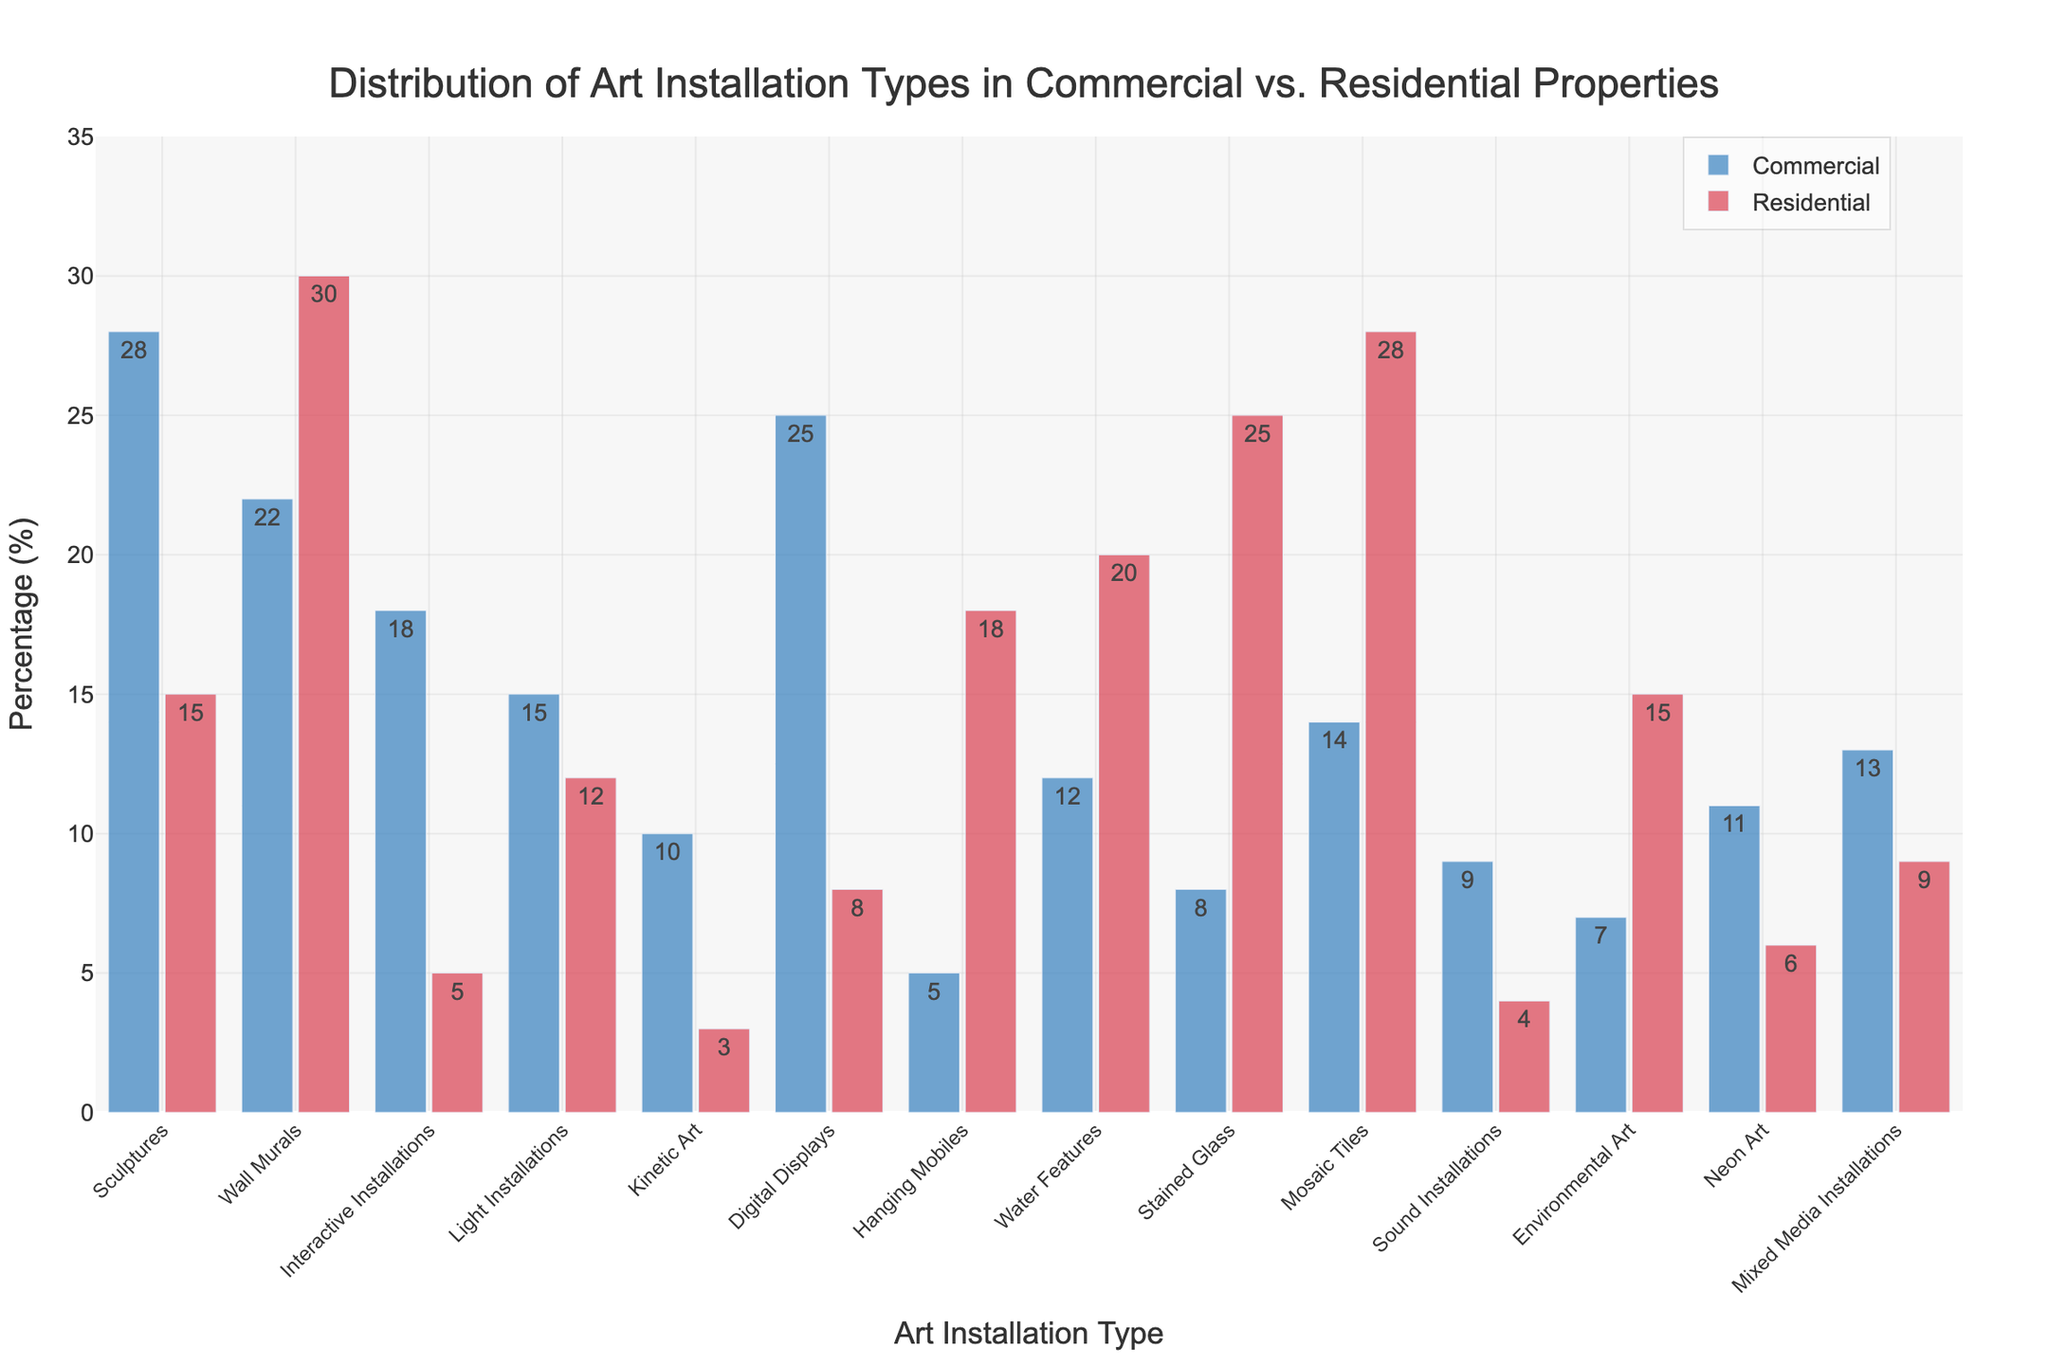What is the difference in percentage between commercial and residential properties for Digital Displays? For commercial, Digital Displays have a percentage of 25%, and for residential, it's 8%. The difference is 25% - 8% = 17%.
Answer: 17% Which type of art installation has the highest percentage in residential properties? According to the figure, Mosaic Tiles have the highest percentage in residential properties at 28%.
Answer: Mosaic Tiles Are Water Features more common in residential or commercial properties? Water Features are more common in residential properties, with a percentage of 20%, compared to 12% in commercial properties.
Answer: Residential What is the combined percentage of Sculptures and Wall Murals in commercial properties? In the figure, Sculptures are at 28% and Wall Murals at 22% in commercial. Their combined percentage is 28% + 22% = 50%.
Answer: 50% Which type of art installation shows the greatest difference in percentage between commercial and residential properties? Digital Displays show the greatest difference, with 25% in commercial and 8% in residential, resulting in a difference of 17%.
Answer: Digital Displays Are there any art installation types that have the same percentage in both commercial and residential properties? No, the figure shows different percentages for all art installation types in commercial and residential properties.
Answer: No How much more common are Sound Installations in commercial properties compared to residential properties? Sound Installations are at 9% in commercial and 4% in residential properties. The difference is 9% - 4% = 5%.
Answer: 5% What percentage of residential properties have Environmental Art installations? The figure indicates that Environmental Art installations are at 15% in residential properties.
Answer: 15% What is the sum of percentages for Light Installations and Kinetic Art in commercial properties? Light Installations in commercial are at 15%, and Kinetic Art is at 10%. Their combined percentage is 15% + 10% = 25%.
Answer: 25% Which installation type has a higher percentage in residential properties compared to commercial properties and by how much? Stained Glass has 25% in residential and 8% in commercial. The difference is 25% - 8% = 17%.
Answer: Stained Glass by 17% 